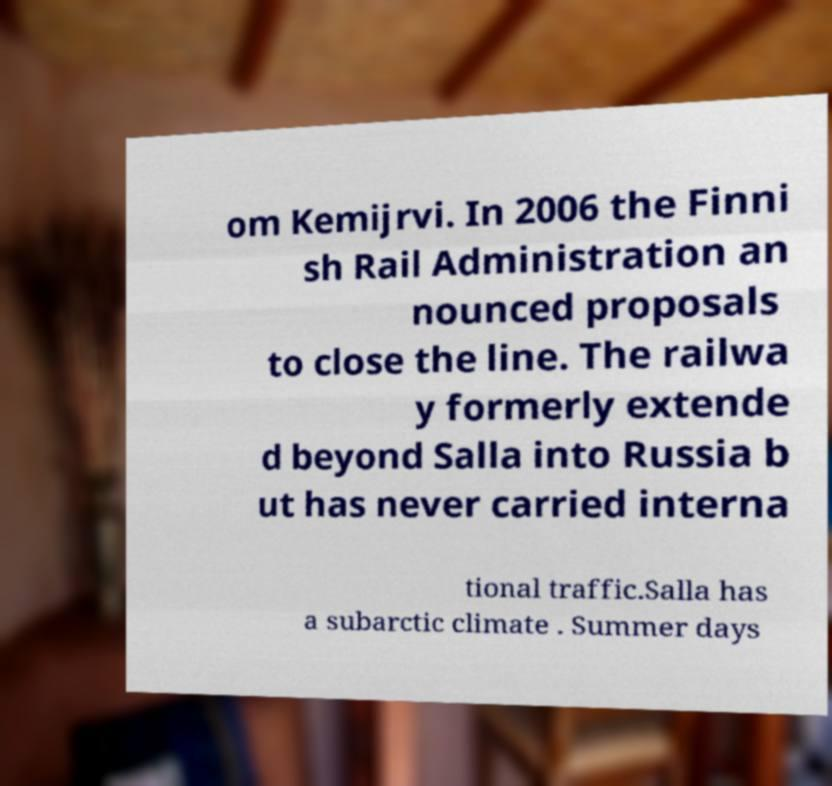I need the written content from this picture converted into text. Can you do that? om Kemijrvi. In 2006 the Finni sh Rail Administration an nounced proposals to close the line. The railwa y formerly extende d beyond Salla into Russia b ut has never carried interna tional traffic.Salla has a subarctic climate . Summer days 